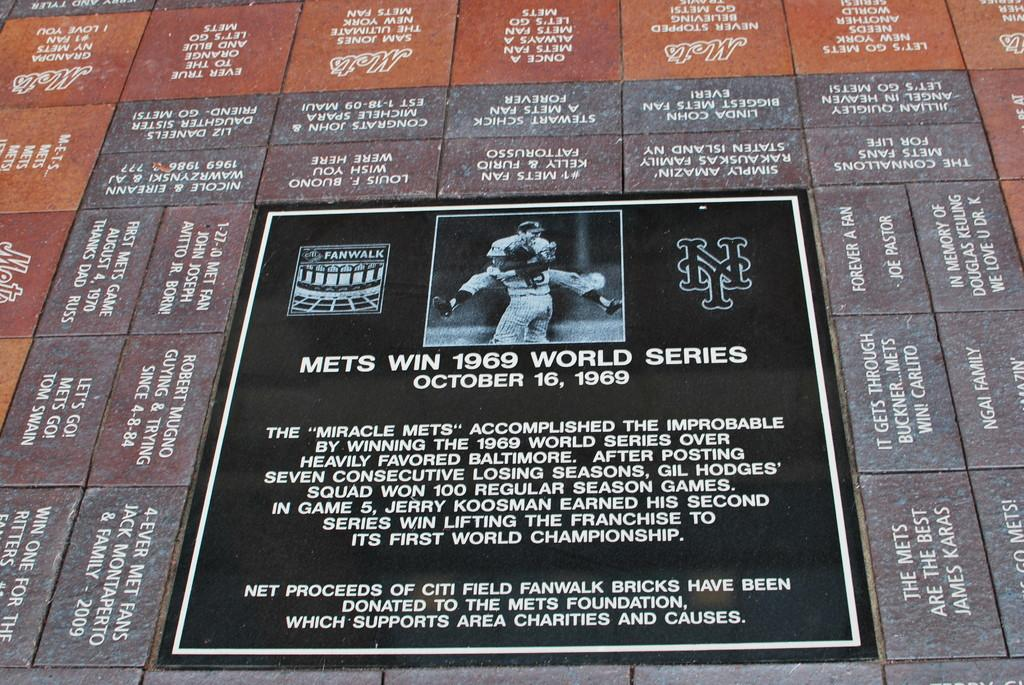<image>
Describe the image concisely. A flat statue of the mets win the 1969 wold series. 